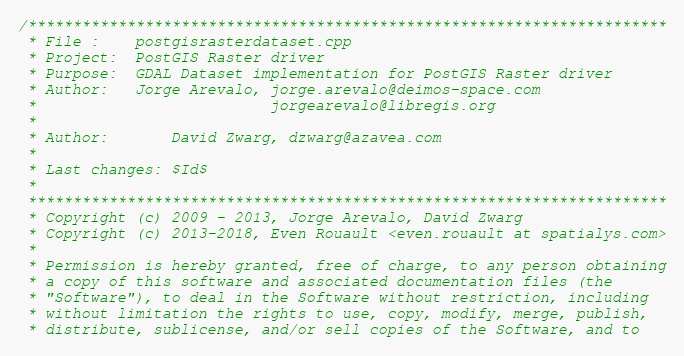Convert code to text. <code><loc_0><loc_0><loc_500><loc_500><_C++_>/***********************************************************************
 * File :    postgisrasterdataset.cpp
 * Project:  PostGIS Raster driver
 * Purpose:  GDAL Dataset implementation for PostGIS Raster driver
 * Author:   Jorge Arevalo, jorge.arevalo@deimos-space.com
 *                          jorgearevalo@libregis.org
 *
 * Author:       David Zwarg, dzwarg@azavea.com
 *
 * Last changes: $Id$
 *
 ***********************************************************************
 * Copyright (c) 2009 - 2013, Jorge Arevalo, David Zwarg
 * Copyright (c) 2013-2018, Even Rouault <even.rouault at spatialys.com>
 *
 * Permission is hereby granted, free of charge, to any person obtaining
 * a copy of this software and associated documentation files (the
 * "Software"), to deal in the Software without restriction, including
 * without limitation the rights to use, copy, modify, merge, publish,
 * distribute, sublicense, and/or sell copies of the Software, and to</code> 